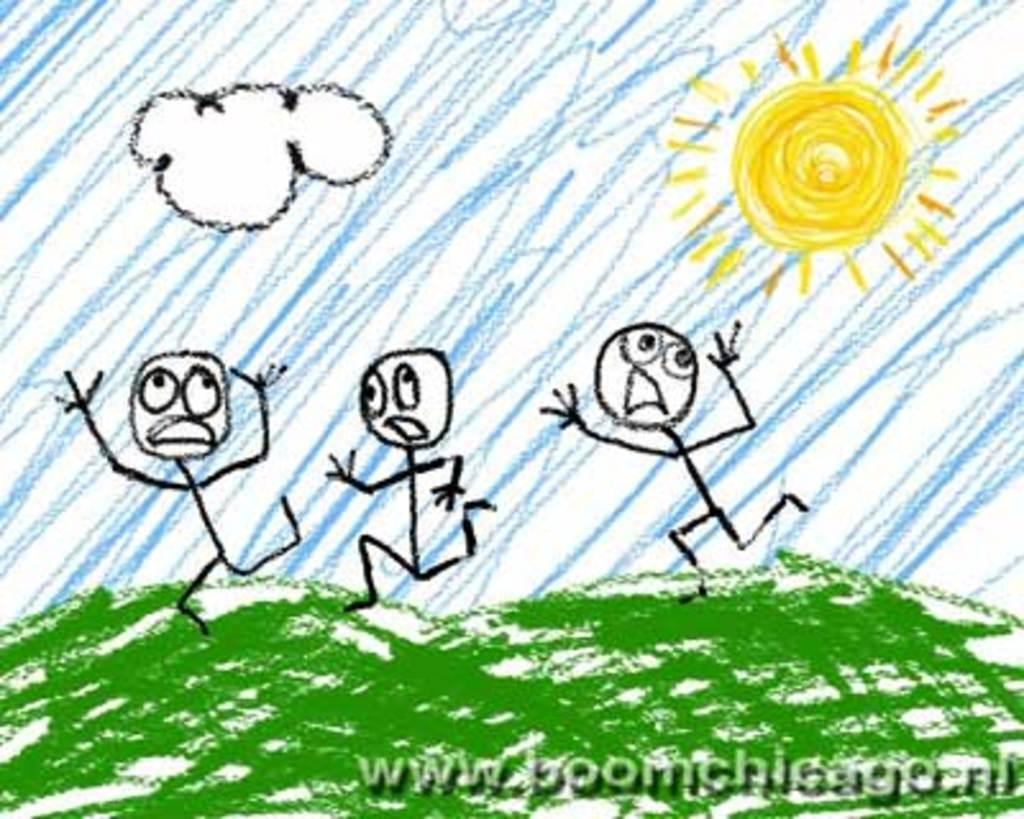What is the main subject of the drawing in the image? The drawing depicts three people. What celestial body is included in the drawing? The drawing includes a sun. What weather element is included in the drawing? The drawing includes a cloud. What colors are used in the drawing? The colors used in the drawing are green, white, blue, and yellow. What type of quill is being used by the people in the drawing? There is no quill present in the drawing; it is a depiction of people, a sun, and a cloud. How is the rake being used by the people in the drawing? There is no rake present in the drawing; it is a depiction of people, a sun, and a cloud. 